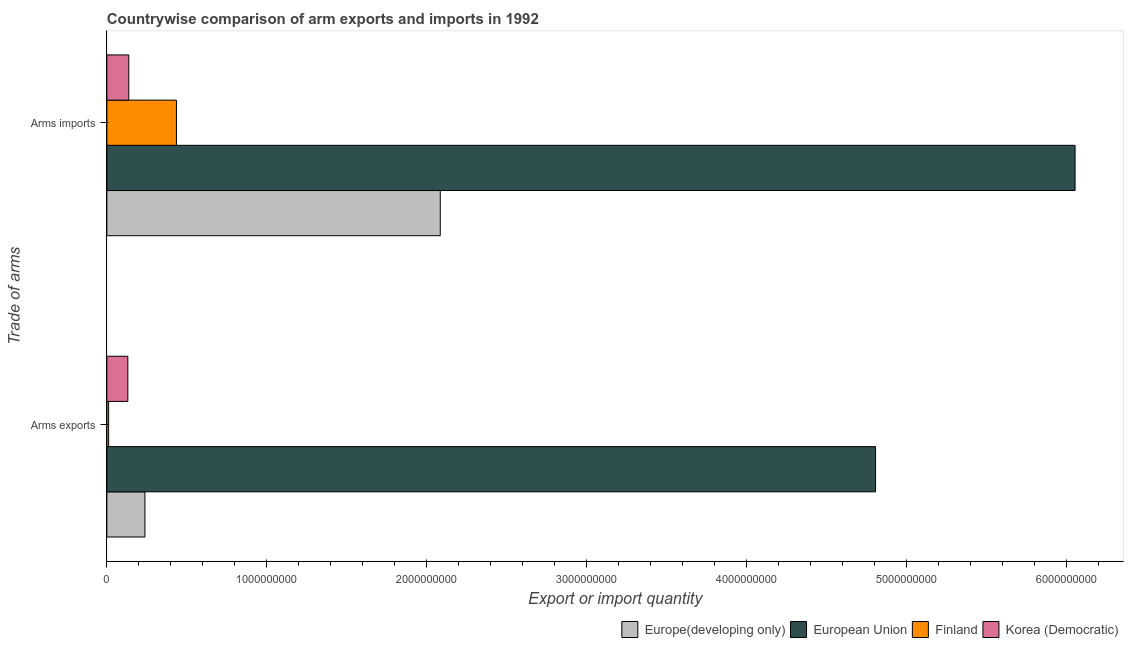How many different coloured bars are there?
Keep it short and to the point. 4. Are the number of bars per tick equal to the number of legend labels?
Keep it short and to the point. Yes. What is the label of the 1st group of bars from the top?
Offer a terse response. Arms imports. What is the arms imports in European Union?
Your answer should be compact. 6.06e+09. Across all countries, what is the maximum arms imports?
Provide a short and direct response. 6.06e+09. Across all countries, what is the minimum arms imports?
Offer a very short reply. 1.37e+08. What is the total arms imports in the graph?
Give a very brief answer. 8.71e+09. What is the difference between the arms imports in Korea (Democratic) and that in Europe(developing only)?
Give a very brief answer. -1.95e+09. What is the difference between the arms imports in Europe(developing only) and the arms exports in European Union?
Your answer should be very brief. -2.72e+09. What is the average arms exports per country?
Offer a terse response. 1.30e+09. What is the difference between the arms exports and arms imports in Korea (Democratic)?
Provide a succinct answer. -6.00e+06. In how many countries, is the arms imports greater than 3200000000 ?
Provide a succinct answer. 1. What is the ratio of the arms imports in Finland to that in Europe(developing only)?
Provide a succinct answer. 0.21. In how many countries, is the arms imports greater than the average arms imports taken over all countries?
Provide a succinct answer. 1. What does the 1st bar from the top in Arms exports represents?
Your answer should be compact. Korea (Democratic). What does the 3rd bar from the bottom in Arms exports represents?
Offer a terse response. Finland. Are all the bars in the graph horizontal?
Keep it short and to the point. Yes. How many countries are there in the graph?
Your answer should be very brief. 4. What is the difference between two consecutive major ticks on the X-axis?
Provide a short and direct response. 1.00e+09. Are the values on the major ticks of X-axis written in scientific E-notation?
Your answer should be compact. No. Where does the legend appear in the graph?
Your answer should be compact. Bottom right. How many legend labels are there?
Ensure brevity in your answer.  4. What is the title of the graph?
Make the answer very short. Countrywise comparison of arm exports and imports in 1992. What is the label or title of the X-axis?
Your answer should be very brief. Export or import quantity. What is the label or title of the Y-axis?
Make the answer very short. Trade of arms. What is the Export or import quantity in Europe(developing only) in Arms exports?
Ensure brevity in your answer.  2.38e+08. What is the Export or import quantity in European Union in Arms exports?
Offer a terse response. 4.81e+09. What is the Export or import quantity in Finland in Arms exports?
Your answer should be compact. 1.10e+07. What is the Export or import quantity in Korea (Democratic) in Arms exports?
Offer a terse response. 1.31e+08. What is the Export or import quantity of Europe(developing only) in Arms imports?
Your answer should be compact. 2.08e+09. What is the Export or import quantity of European Union in Arms imports?
Your answer should be very brief. 6.06e+09. What is the Export or import quantity of Finland in Arms imports?
Give a very brief answer. 4.35e+08. What is the Export or import quantity in Korea (Democratic) in Arms imports?
Offer a terse response. 1.37e+08. Across all Trade of arms, what is the maximum Export or import quantity of Europe(developing only)?
Your response must be concise. 2.08e+09. Across all Trade of arms, what is the maximum Export or import quantity in European Union?
Give a very brief answer. 6.06e+09. Across all Trade of arms, what is the maximum Export or import quantity of Finland?
Give a very brief answer. 4.35e+08. Across all Trade of arms, what is the maximum Export or import quantity of Korea (Democratic)?
Offer a terse response. 1.37e+08. Across all Trade of arms, what is the minimum Export or import quantity of Europe(developing only)?
Provide a succinct answer. 2.38e+08. Across all Trade of arms, what is the minimum Export or import quantity of European Union?
Offer a terse response. 4.81e+09. Across all Trade of arms, what is the minimum Export or import quantity of Finland?
Offer a very short reply. 1.10e+07. Across all Trade of arms, what is the minimum Export or import quantity of Korea (Democratic)?
Offer a terse response. 1.31e+08. What is the total Export or import quantity in Europe(developing only) in the graph?
Provide a succinct answer. 2.32e+09. What is the total Export or import quantity in European Union in the graph?
Offer a very short reply. 1.09e+1. What is the total Export or import quantity in Finland in the graph?
Ensure brevity in your answer.  4.46e+08. What is the total Export or import quantity of Korea (Democratic) in the graph?
Offer a terse response. 2.68e+08. What is the difference between the Export or import quantity in Europe(developing only) in Arms exports and that in Arms imports?
Ensure brevity in your answer.  -1.85e+09. What is the difference between the Export or import quantity in European Union in Arms exports and that in Arms imports?
Provide a succinct answer. -1.25e+09. What is the difference between the Export or import quantity of Finland in Arms exports and that in Arms imports?
Offer a very short reply. -4.24e+08. What is the difference between the Export or import quantity of Korea (Democratic) in Arms exports and that in Arms imports?
Make the answer very short. -6.00e+06. What is the difference between the Export or import quantity of Europe(developing only) in Arms exports and the Export or import quantity of European Union in Arms imports?
Make the answer very short. -5.82e+09. What is the difference between the Export or import quantity in Europe(developing only) in Arms exports and the Export or import quantity in Finland in Arms imports?
Your response must be concise. -1.97e+08. What is the difference between the Export or import quantity of Europe(developing only) in Arms exports and the Export or import quantity of Korea (Democratic) in Arms imports?
Your answer should be very brief. 1.01e+08. What is the difference between the Export or import quantity of European Union in Arms exports and the Export or import quantity of Finland in Arms imports?
Provide a short and direct response. 4.37e+09. What is the difference between the Export or import quantity of European Union in Arms exports and the Export or import quantity of Korea (Democratic) in Arms imports?
Your answer should be compact. 4.67e+09. What is the difference between the Export or import quantity in Finland in Arms exports and the Export or import quantity in Korea (Democratic) in Arms imports?
Your answer should be very brief. -1.26e+08. What is the average Export or import quantity in Europe(developing only) per Trade of arms?
Give a very brief answer. 1.16e+09. What is the average Export or import quantity of European Union per Trade of arms?
Make the answer very short. 5.43e+09. What is the average Export or import quantity of Finland per Trade of arms?
Your answer should be compact. 2.23e+08. What is the average Export or import quantity of Korea (Democratic) per Trade of arms?
Your answer should be very brief. 1.34e+08. What is the difference between the Export or import quantity of Europe(developing only) and Export or import quantity of European Union in Arms exports?
Provide a succinct answer. -4.57e+09. What is the difference between the Export or import quantity of Europe(developing only) and Export or import quantity of Finland in Arms exports?
Offer a very short reply. 2.27e+08. What is the difference between the Export or import quantity in Europe(developing only) and Export or import quantity in Korea (Democratic) in Arms exports?
Ensure brevity in your answer.  1.07e+08. What is the difference between the Export or import quantity of European Union and Export or import quantity of Finland in Arms exports?
Offer a very short reply. 4.80e+09. What is the difference between the Export or import quantity in European Union and Export or import quantity in Korea (Democratic) in Arms exports?
Keep it short and to the point. 4.68e+09. What is the difference between the Export or import quantity of Finland and Export or import quantity of Korea (Democratic) in Arms exports?
Make the answer very short. -1.20e+08. What is the difference between the Export or import quantity in Europe(developing only) and Export or import quantity in European Union in Arms imports?
Provide a short and direct response. -3.97e+09. What is the difference between the Export or import quantity of Europe(developing only) and Export or import quantity of Finland in Arms imports?
Your response must be concise. 1.65e+09. What is the difference between the Export or import quantity in Europe(developing only) and Export or import quantity in Korea (Democratic) in Arms imports?
Ensure brevity in your answer.  1.95e+09. What is the difference between the Export or import quantity of European Union and Export or import quantity of Finland in Arms imports?
Provide a succinct answer. 5.62e+09. What is the difference between the Export or import quantity of European Union and Export or import quantity of Korea (Democratic) in Arms imports?
Give a very brief answer. 5.92e+09. What is the difference between the Export or import quantity of Finland and Export or import quantity of Korea (Democratic) in Arms imports?
Offer a terse response. 2.98e+08. What is the ratio of the Export or import quantity in Europe(developing only) in Arms exports to that in Arms imports?
Your answer should be very brief. 0.11. What is the ratio of the Export or import quantity of European Union in Arms exports to that in Arms imports?
Your answer should be compact. 0.79. What is the ratio of the Export or import quantity of Finland in Arms exports to that in Arms imports?
Provide a succinct answer. 0.03. What is the ratio of the Export or import quantity of Korea (Democratic) in Arms exports to that in Arms imports?
Your response must be concise. 0.96. What is the difference between the highest and the second highest Export or import quantity of Europe(developing only)?
Ensure brevity in your answer.  1.85e+09. What is the difference between the highest and the second highest Export or import quantity in European Union?
Your answer should be compact. 1.25e+09. What is the difference between the highest and the second highest Export or import quantity of Finland?
Provide a short and direct response. 4.24e+08. What is the difference between the highest and the lowest Export or import quantity of Europe(developing only)?
Your answer should be very brief. 1.85e+09. What is the difference between the highest and the lowest Export or import quantity of European Union?
Provide a short and direct response. 1.25e+09. What is the difference between the highest and the lowest Export or import quantity in Finland?
Your answer should be compact. 4.24e+08. 